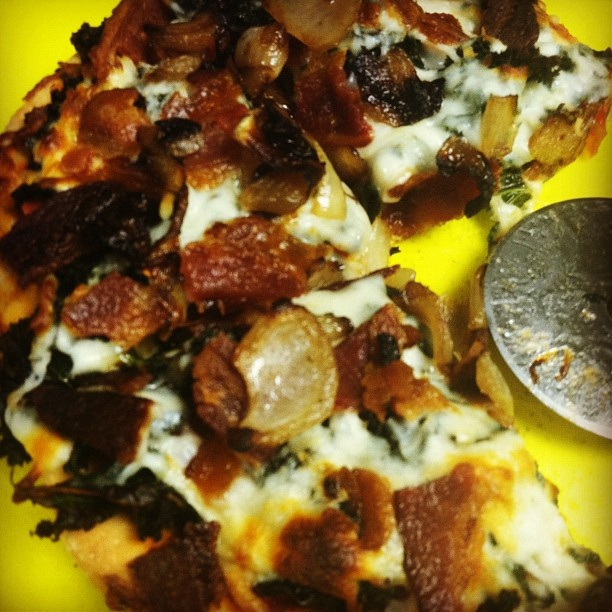Describe the objects in this image and their specific colors. I can see pizza in black, olive, maroon, brown, and khaki tones and spoon in olive, gray, darkgreen, and black tones in this image. 